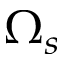Convert formula to latex. <formula><loc_0><loc_0><loc_500><loc_500>\Omega _ { s }</formula> 